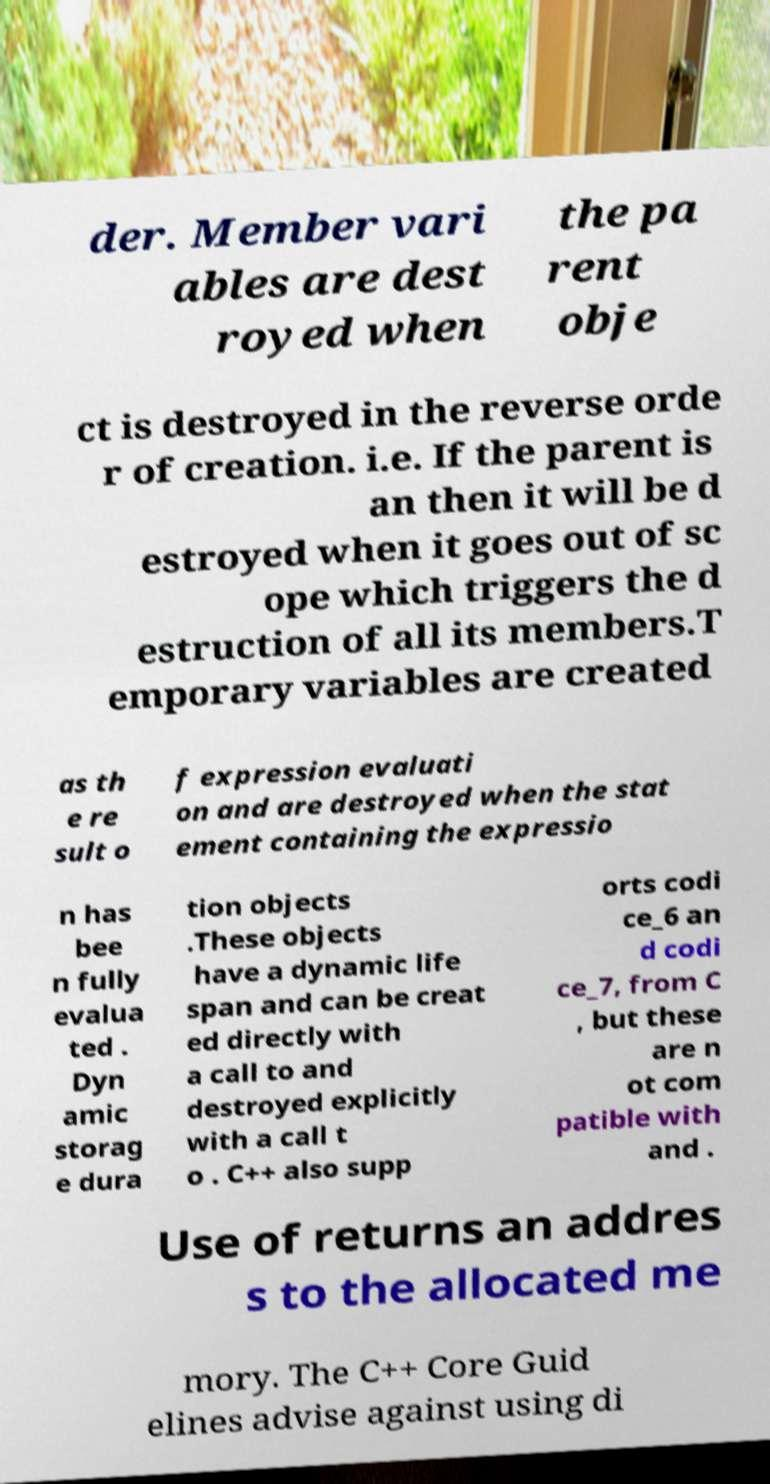Can you accurately transcribe the text from the provided image for me? der. Member vari ables are dest royed when the pa rent obje ct is destroyed in the reverse orde r of creation. i.e. If the parent is an then it will be d estroyed when it goes out of sc ope which triggers the d estruction of all its members.T emporary variables are created as th e re sult o f expression evaluati on and are destroyed when the stat ement containing the expressio n has bee n fully evalua ted . Dyn amic storag e dura tion objects .These objects have a dynamic life span and can be creat ed directly with a call to and destroyed explicitly with a call t o . C++ also supp orts codi ce_6 an d codi ce_7, from C , but these are n ot com patible with and . Use of returns an addres s to the allocated me mory. The C++ Core Guid elines advise against using di 